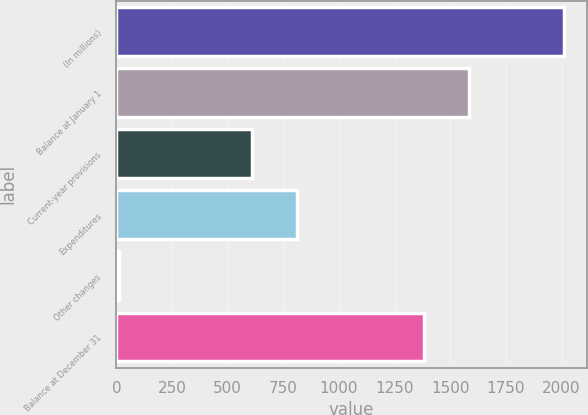<chart> <loc_0><loc_0><loc_500><loc_500><bar_chart><fcel>(In millions)<fcel>Balance at January 1<fcel>Current-year provisions<fcel>Expenditures<fcel>Other changes<fcel>Balance at December 31<nl><fcel>2012<fcel>1583<fcel>611<fcel>811<fcel>12<fcel>1383<nl></chart> 